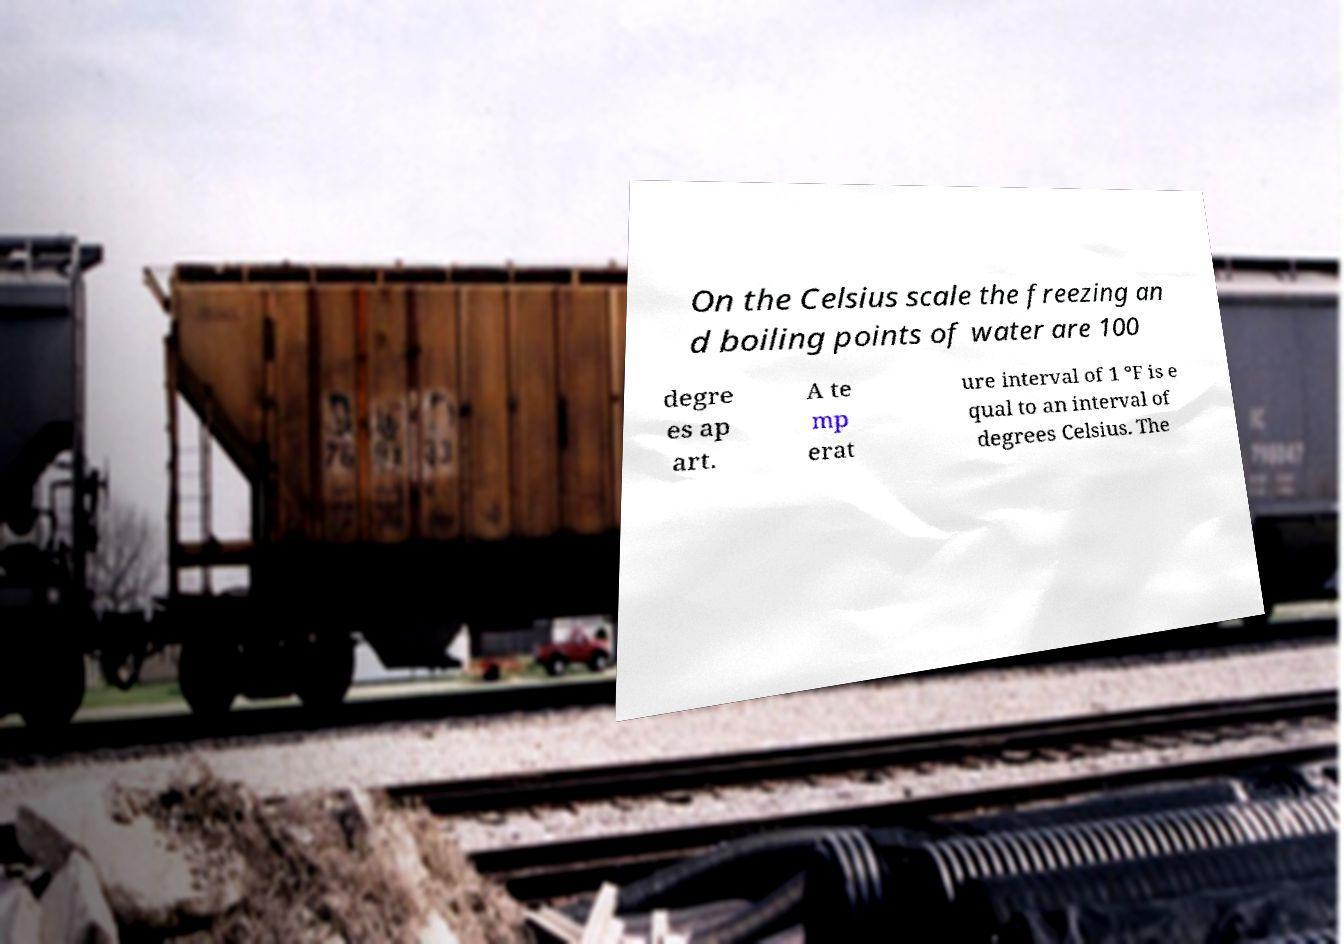Can you read and provide the text displayed in the image?This photo seems to have some interesting text. Can you extract and type it out for me? On the Celsius scale the freezing an d boiling points of water are 100 degre es ap art. A te mp erat ure interval of 1 °F is e qual to an interval of degrees Celsius. The 